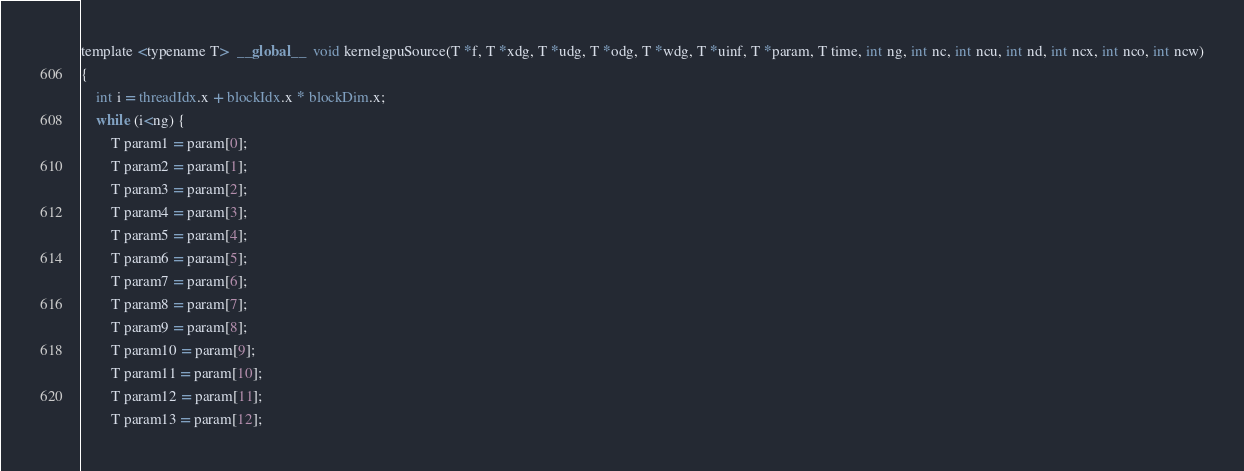<code> <loc_0><loc_0><loc_500><loc_500><_Cuda_>template <typename T>  __global__  void kernelgpuSource(T *f, T *xdg, T *udg, T *odg, T *wdg, T *uinf, T *param, T time, int ng, int nc, int ncu, int nd, int ncx, int nco, int ncw)
{
	int i = threadIdx.x + blockIdx.x * blockDim.x;
	while (i<ng) {
		T param1 = param[0];
		T param2 = param[1];
		T param3 = param[2];
		T param4 = param[3];
		T param5 = param[4];
		T param6 = param[5];
		T param7 = param[6];
		T param8 = param[7];
		T param9 = param[8];
		T param10 = param[9];
		T param11 = param[10];
		T param12 = param[11];
		T param13 = param[12];</code> 